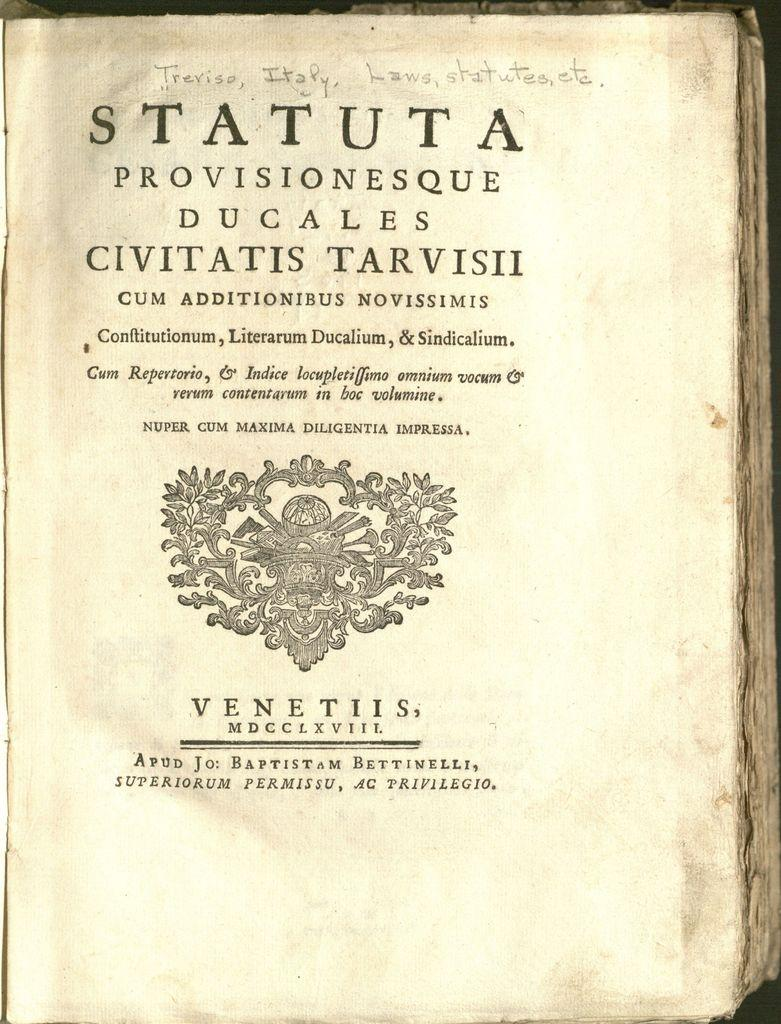<image>
Present a compact description of the photo's key features. A page of an ancient book in Latin with a title on top that says "statuta" 